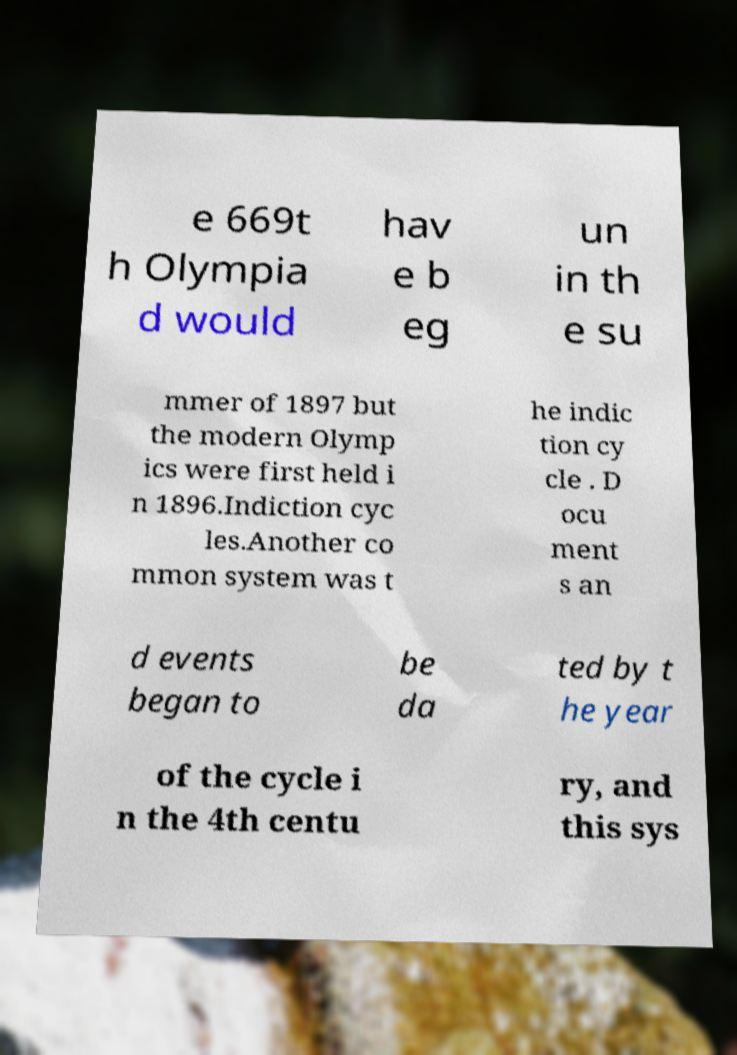Could you assist in decoding the text presented in this image and type it out clearly? e 669t h Olympia d would hav e b eg un in th e su mmer of 1897 but the modern Olymp ics were first held i n 1896.Indiction cyc les.Another co mmon system was t he indic tion cy cle . D ocu ment s an d events began to be da ted by t he year of the cycle i n the 4th centu ry, and this sys 